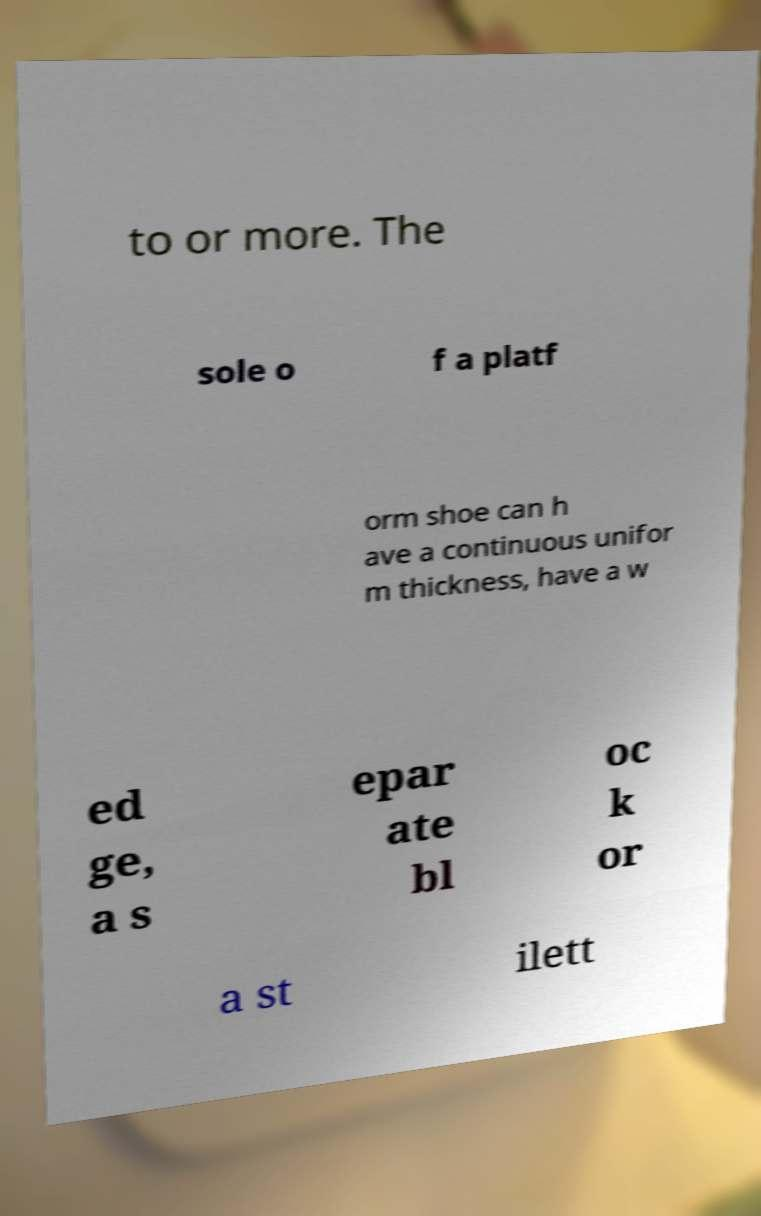There's text embedded in this image that I need extracted. Can you transcribe it verbatim? to or more. The sole o f a platf orm shoe can h ave a continuous unifor m thickness, have a w ed ge, a s epar ate bl oc k or a st ilett 